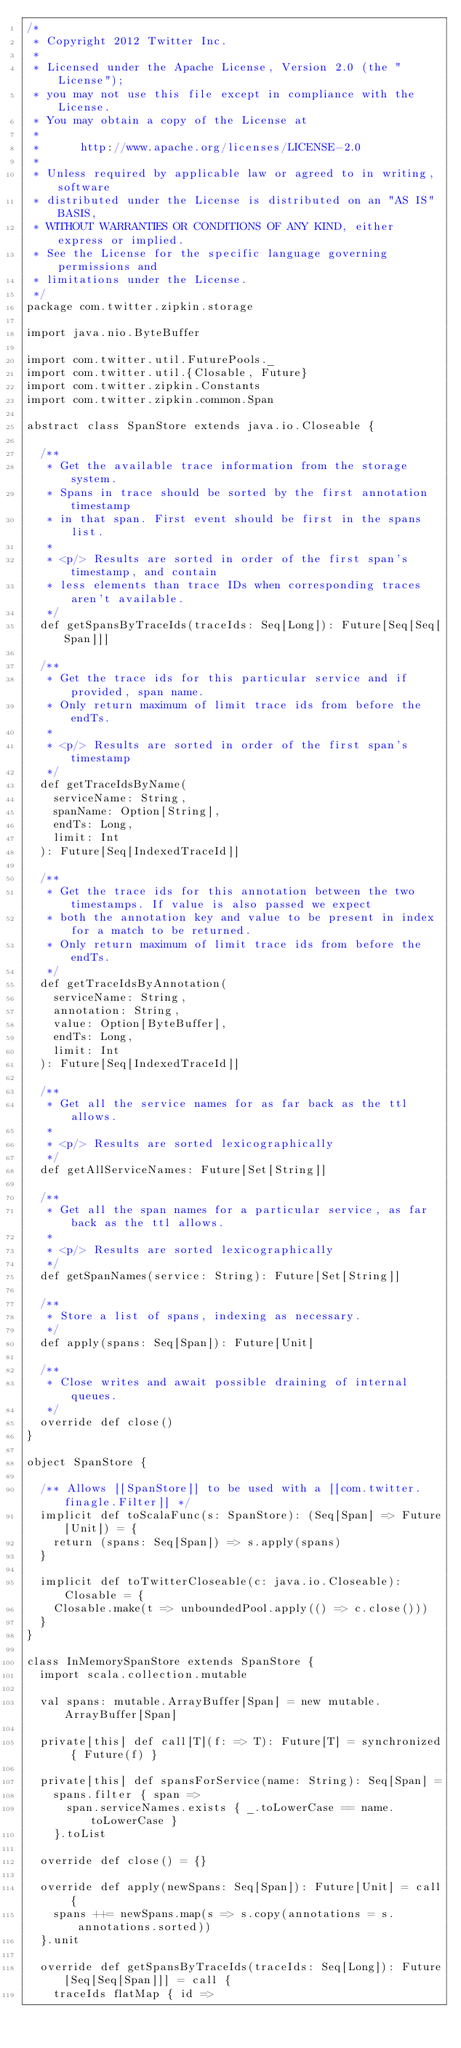<code> <loc_0><loc_0><loc_500><loc_500><_Scala_>/*
 * Copyright 2012 Twitter Inc.
 *
 * Licensed under the Apache License, Version 2.0 (the "License");
 * you may not use this file except in compliance with the License.
 * You may obtain a copy of the License at
 *
 *      http://www.apache.org/licenses/LICENSE-2.0
 *
 * Unless required by applicable law or agreed to in writing, software
 * distributed under the License is distributed on an "AS IS" BASIS,
 * WITHOUT WARRANTIES OR CONDITIONS OF ANY KIND, either express or implied.
 * See the License for the specific language governing permissions and
 * limitations under the License.
 */
package com.twitter.zipkin.storage

import java.nio.ByteBuffer

import com.twitter.util.FuturePools._
import com.twitter.util.{Closable, Future}
import com.twitter.zipkin.Constants
import com.twitter.zipkin.common.Span

abstract class SpanStore extends java.io.Closeable {

  /**
   * Get the available trace information from the storage system.
   * Spans in trace should be sorted by the first annotation timestamp
   * in that span. First event should be first in the spans list.
   *
   * <p/> Results are sorted in order of the first span's timestamp, and contain
   * less elements than trace IDs when corresponding traces aren't available.
   */
  def getSpansByTraceIds(traceIds: Seq[Long]): Future[Seq[Seq[Span]]]

  /**
   * Get the trace ids for this particular service and if provided, span name.
   * Only return maximum of limit trace ids from before the endTs.
   *
   * <p/> Results are sorted in order of the first span's timestamp
   */
  def getTraceIdsByName(
    serviceName: String,
    spanName: Option[String],
    endTs: Long,
    limit: Int
  ): Future[Seq[IndexedTraceId]]

  /**
   * Get the trace ids for this annotation between the two timestamps. If value is also passed we expect
   * both the annotation key and value to be present in index for a match to be returned.
   * Only return maximum of limit trace ids from before the endTs.
   */
  def getTraceIdsByAnnotation(
    serviceName: String,
    annotation: String,
    value: Option[ByteBuffer],
    endTs: Long,
    limit: Int
  ): Future[Seq[IndexedTraceId]]

  /**
   * Get all the service names for as far back as the ttl allows.
   *
   * <p/> Results are sorted lexicographically
   */
  def getAllServiceNames: Future[Set[String]]

  /**
   * Get all the span names for a particular service, as far back as the ttl allows.
   *
   * <p/> Results are sorted lexicographically
   */
  def getSpanNames(service: String): Future[Set[String]]

  /**
   * Store a list of spans, indexing as necessary.
   */
  def apply(spans: Seq[Span]): Future[Unit]

  /**
   * Close writes and await possible draining of internal queues.
   */
  override def close()
}

object SpanStore {

  /** Allows [[SpanStore]] to be used with a [[com.twitter.finagle.Filter]] */
  implicit def toScalaFunc(s: SpanStore): (Seq[Span] => Future[Unit]) = {
    return (spans: Seq[Span]) => s.apply(spans)
  }

  implicit def toTwitterCloseable(c: java.io.Closeable): Closable = {
    Closable.make(t => unboundedPool.apply(() => c.close()))
  }
}

class InMemorySpanStore extends SpanStore {
  import scala.collection.mutable

  val spans: mutable.ArrayBuffer[Span] = new mutable.ArrayBuffer[Span]

  private[this] def call[T](f: => T): Future[T] = synchronized { Future(f) }

  private[this] def spansForService(name: String): Seq[Span] =
    spans.filter { span =>
      span.serviceNames.exists { _.toLowerCase == name.toLowerCase }
    }.toList

  override def close() = {}

  override def apply(newSpans: Seq[Span]): Future[Unit] = call {
    spans ++= newSpans.map(s => s.copy(annotations = s.annotations.sorted))
  }.unit

  override def getSpansByTraceIds(traceIds: Seq[Long]): Future[Seq[Seq[Span]]] = call {
    traceIds flatMap { id =></code> 